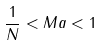<formula> <loc_0><loc_0><loc_500><loc_500>\frac { 1 } { N } < M a < 1</formula> 